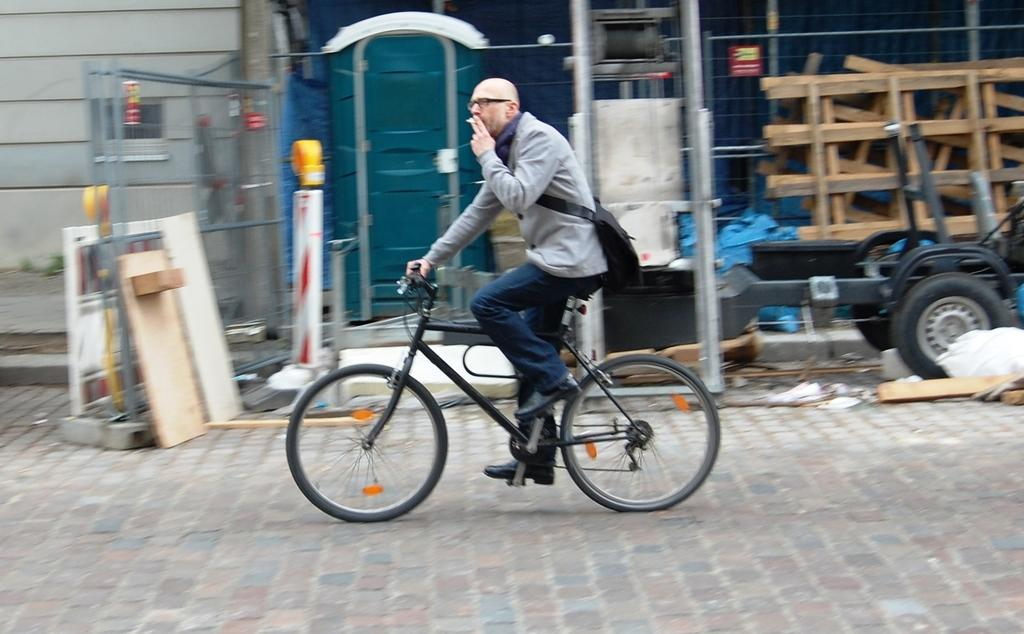What is the main subject of the image? The main subject of the image is a man. What is the man doing in the image? The man is on a cycle in the image. What is the man wearing in the image? The man is wearing a bag in the image. What can be seen in the background of the image? There is a building, a vehicle, and additional unspecified objects in the background of the image. What type of goldfish is swimming in the man's bag in the image? There is no goldfish present in the image; the man is wearing a bag, but there is no indication of a goldfish or any other living creature inside it. 